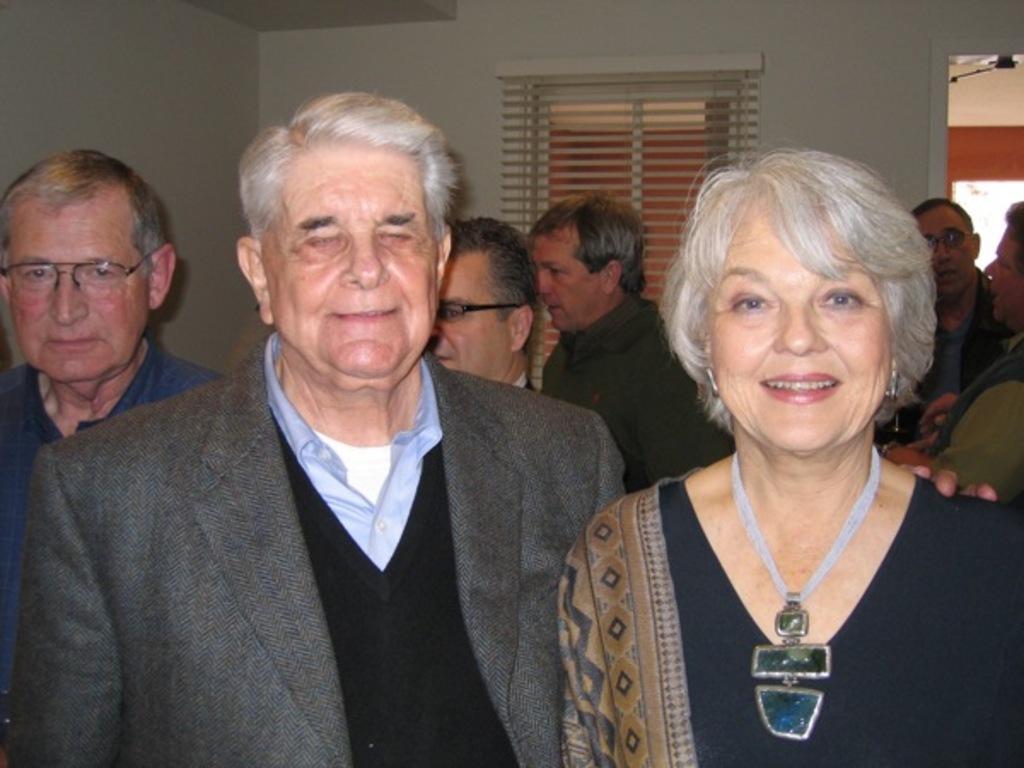Please provide a concise description of this image. In this image I can see a woman wearing black and brown colored dress and a person wearing blue, black and grey colored dress are standing. In the background I can see few persons standing, the wall, the window and the door. 